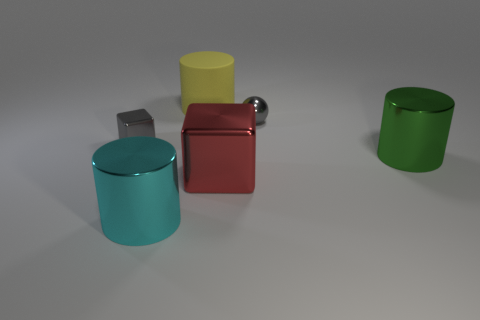The large shiny object on the left side of the red shiny thing has what shape? cylinder 